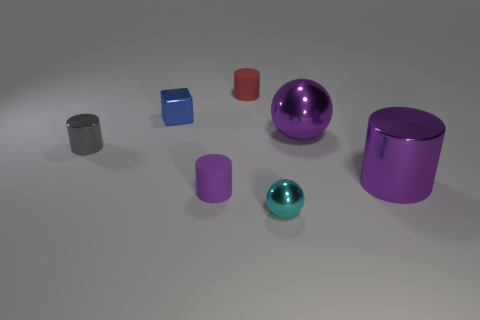Are there any purple objects right of the big purple metallic ball?
Ensure brevity in your answer.  Yes. Is there a tiny red thing that has the same material as the tiny purple cylinder?
Offer a very short reply. Yes. What is the size of the shiny cylinder that is the same color as the large sphere?
Give a very brief answer. Large. How many balls are small purple shiny objects or small metal objects?
Your answer should be very brief. 1. Is the number of small cyan things in front of the blue metal object greater than the number of metal cylinders that are in front of the purple rubber cylinder?
Offer a terse response. Yes. How many spheres are the same color as the small shiny cylinder?
Your answer should be compact. 0. What size is the purple thing that is the same material as the large purple ball?
Give a very brief answer. Large. What number of things are cylinders behind the gray shiny thing or big brown matte cylinders?
Make the answer very short. 1. Is the color of the small rubber thing in front of the tiny red cylinder the same as the big shiny sphere?
Your answer should be very brief. Yes. There is another purple thing that is the same shape as the tiny purple object; what is its size?
Provide a succinct answer. Large. 